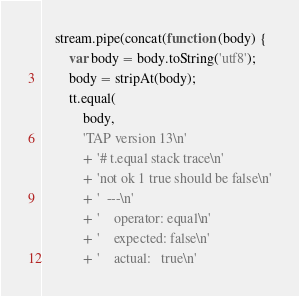<code> <loc_0><loc_0><loc_500><loc_500><_JavaScript_>
    stream.pipe(concat(function (body) {
        var body = body.toString('utf8');
        body = stripAt(body);
        tt.equal(
            body,
            'TAP version 13\n'
            + '# t.equal stack trace\n'
            + 'not ok 1 true should be false\n'
            + '  ---\n'
            + '    operator: equal\n'
            + '    expected: false\n'
            + '    actual:   true\n'</code> 